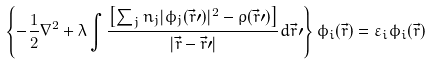<formula> <loc_0><loc_0><loc_500><loc_500>\left \{ - \frac { 1 } { 2 } \nabla ^ { 2 } + \lambda \int \frac { \left [ \sum _ { j } n _ { j } | \phi _ { j } ( \vec { r } \prime ) | ^ { 2 } - \rho ( \vec { r } \prime ) \right ] } { | \vec { r } - \vec { r } \prime | } d \vec { r } \prime \right \} \phi _ { i } ( \vec { r } ) = \varepsilon _ { i } \phi _ { i } ( \vec { r } )</formula> 